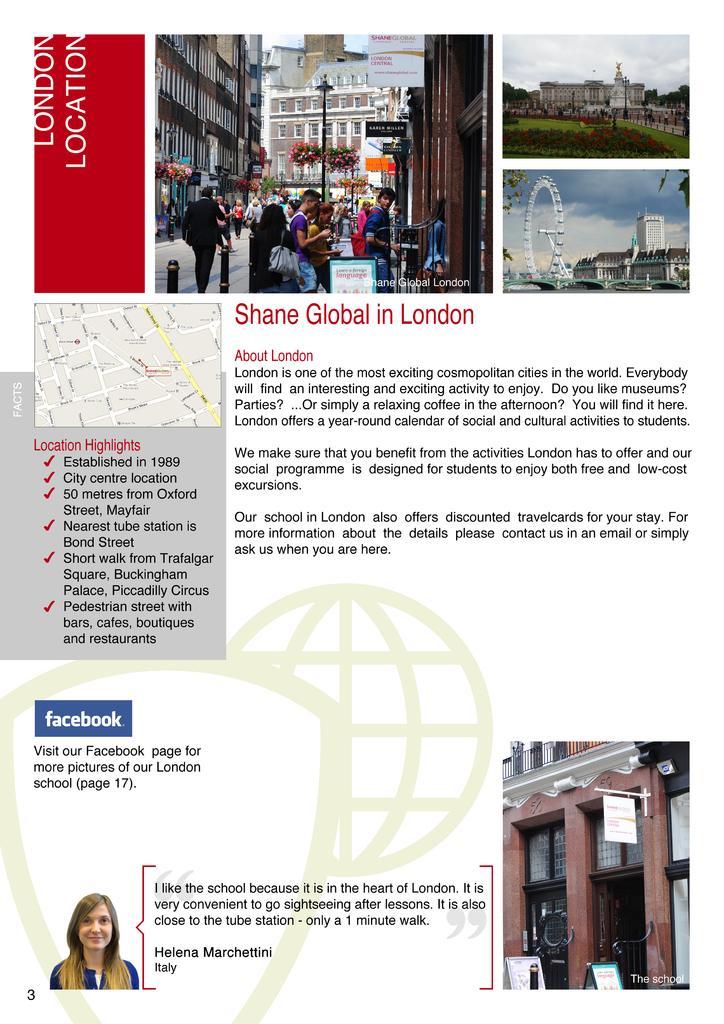Can you describe this image briefly? There is an article on the as we can see there are some images at the top of this image, and there is some text in the middle, and there is a picture of a woman at the bottom left corner, and there is a building at the bottom right corner. 